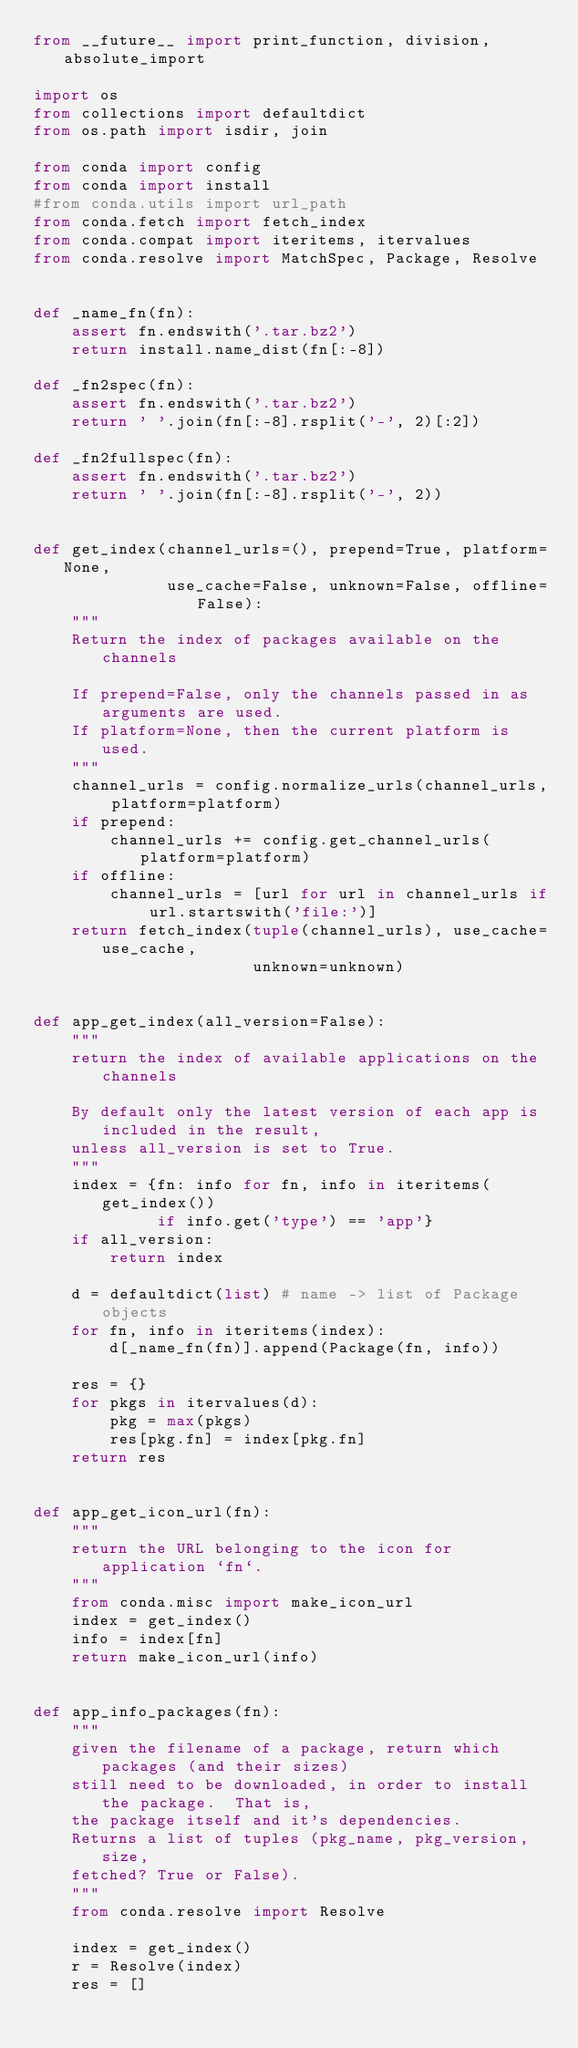<code> <loc_0><loc_0><loc_500><loc_500><_Python_>from __future__ import print_function, division, absolute_import

import os
from collections import defaultdict
from os.path import isdir, join

from conda import config
from conda import install
#from conda.utils import url_path
from conda.fetch import fetch_index
from conda.compat import iteritems, itervalues
from conda.resolve import MatchSpec, Package, Resolve


def _name_fn(fn):
    assert fn.endswith('.tar.bz2')
    return install.name_dist(fn[:-8])

def _fn2spec(fn):
    assert fn.endswith('.tar.bz2')
    return ' '.join(fn[:-8].rsplit('-', 2)[:2])

def _fn2fullspec(fn):
    assert fn.endswith('.tar.bz2')
    return ' '.join(fn[:-8].rsplit('-', 2))


def get_index(channel_urls=(), prepend=True, platform=None,
              use_cache=False, unknown=False, offline=False):
    """
    Return the index of packages available on the channels

    If prepend=False, only the channels passed in as arguments are used.
    If platform=None, then the current platform is used.
    """
    channel_urls = config.normalize_urls(channel_urls, platform=platform)
    if prepend:
        channel_urls += config.get_channel_urls(platform=platform)
    if offline:
        channel_urls = [url for url in channel_urls if url.startswith('file:')]
    return fetch_index(tuple(channel_urls), use_cache=use_cache,
                       unknown=unknown)


def app_get_index(all_version=False):
    """
    return the index of available applications on the channels

    By default only the latest version of each app is included in the result,
    unless all_version is set to True.
    """
    index = {fn: info for fn, info in iteritems(get_index())
             if info.get('type') == 'app'}
    if all_version:
        return index

    d = defaultdict(list) # name -> list of Package objects
    for fn, info in iteritems(index):
        d[_name_fn(fn)].append(Package(fn, info))

    res = {}
    for pkgs in itervalues(d):
        pkg = max(pkgs)
        res[pkg.fn] = index[pkg.fn]
    return res


def app_get_icon_url(fn):
    """
    return the URL belonging to the icon for application `fn`.
    """
    from conda.misc import make_icon_url
    index = get_index()
    info = index[fn]
    return make_icon_url(info)


def app_info_packages(fn):
    """
    given the filename of a package, return which packages (and their sizes)
    still need to be downloaded, in order to install the package.  That is,
    the package itself and it's dependencies.
    Returns a list of tuples (pkg_name, pkg_version, size,
    fetched? True or False).
    """
    from conda.resolve import Resolve

    index = get_index()
    r = Resolve(index)
    res = []</code> 